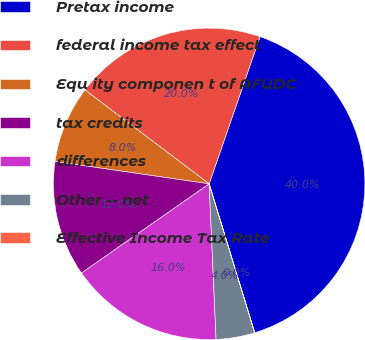Convert chart. <chart><loc_0><loc_0><loc_500><loc_500><pie_chart><fcel>Pretax income<fcel>federal income tax effect<fcel>Equ ity componen t of AFUDC<fcel>tax credits<fcel>differences<fcel>Other -- net<fcel>Effective Income Tax Rate<nl><fcel>39.97%<fcel>19.99%<fcel>8.01%<fcel>12.0%<fcel>16.0%<fcel>4.01%<fcel>0.01%<nl></chart> 